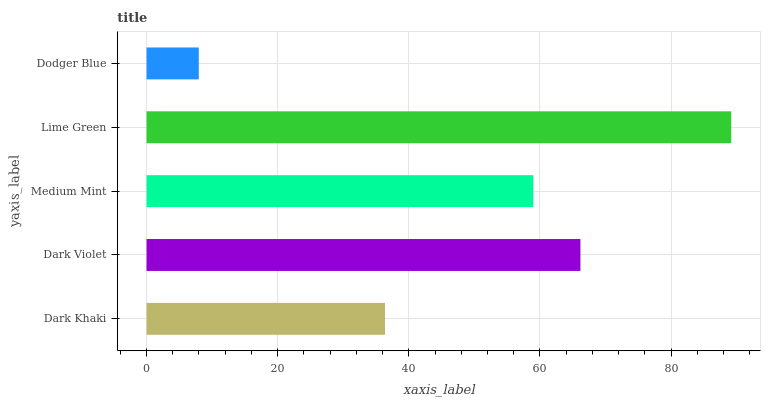Is Dodger Blue the minimum?
Answer yes or no. Yes. Is Lime Green the maximum?
Answer yes or no. Yes. Is Dark Violet the minimum?
Answer yes or no. No. Is Dark Violet the maximum?
Answer yes or no. No. Is Dark Violet greater than Dark Khaki?
Answer yes or no. Yes. Is Dark Khaki less than Dark Violet?
Answer yes or no. Yes. Is Dark Khaki greater than Dark Violet?
Answer yes or no. No. Is Dark Violet less than Dark Khaki?
Answer yes or no. No. Is Medium Mint the high median?
Answer yes or no. Yes. Is Medium Mint the low median?
Answer yes or no. Yes. Is Dodger Blue the high median?
Answer yes or no. No. Is Dodger Blue the low median?
Answer yes or no. No. 